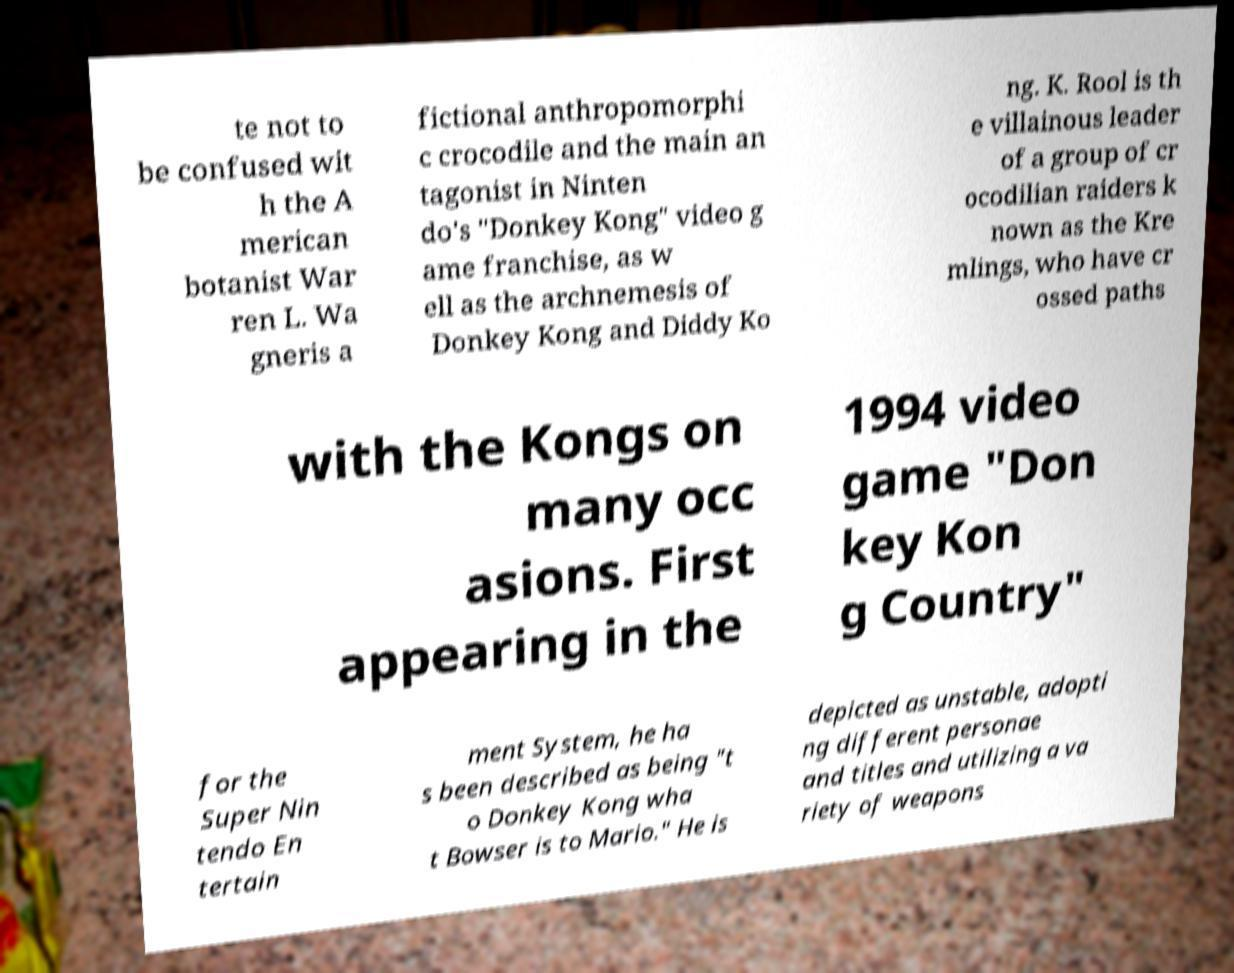Please identify and transcribe the text found in this image. te not to be confused wit h the A merican botanist War ren L. Wa gneris a fictional anthropomorphi c crocodile and the main an tagonist in Ninten do's "Donkey Kong" video g ame franchise, as w ell as the archnemesis of Donkey Kong and Diddy Ko ng. K. Rool is th e villainous leader of a group of cr ocodilian raiders k nown as the Kre mlings, who have cr ossed paths with the Kongs on many occ asions. First appearing in the 1994 video game "Don key Kon g Country" for the Super Nin tendo En tertain ment System, he ha s been described as being "t o Donkey Kong wha t Bowser is to Mario." He is depicted as unstable, adopti ng different personae and titles and utilizing a va riety of weapons 